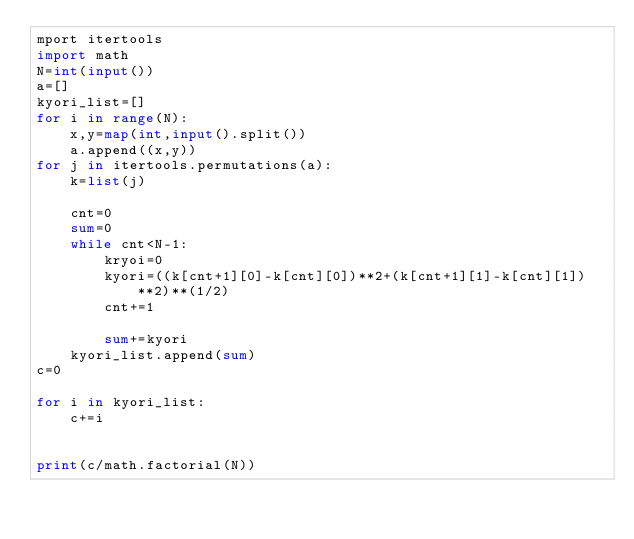Convert code to text. <code><loc_0><loc_0><loc_500><loc_500><_Python_>mport itertools
import math
N=int(input())
a=[]
kyori_list=[]
for i in range(N):
    x,y=map(int,input().split())
    a.append((x,y))
for j in itertools.permutations(a):
    k=list(j)
    
    cnt=0
    sum=0
    while cnt<N-1:
        kryoi=0
        kyori=((k[cnt+1][0]-k[cnt][0])**2+(k[cnt+1][1]-k[cnt][1])**2)**(1/2)
        cnt+=1
        
        sum+=kyori
    kyori_list.append(sum)
c=0

for i in kyori_list:
    c+=i
    
    
print(c/math.factorial(N))</code> 